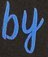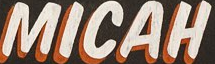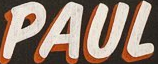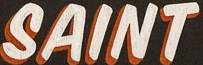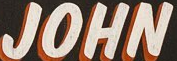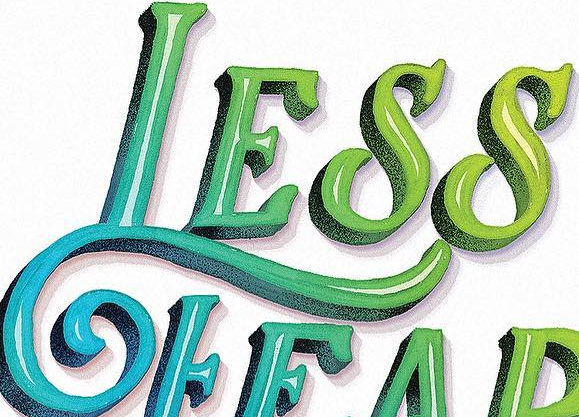Read the text content from these images in order, separated by a semicolon. by; MICAH; PAUL; SAINT; JOHN; LESS 